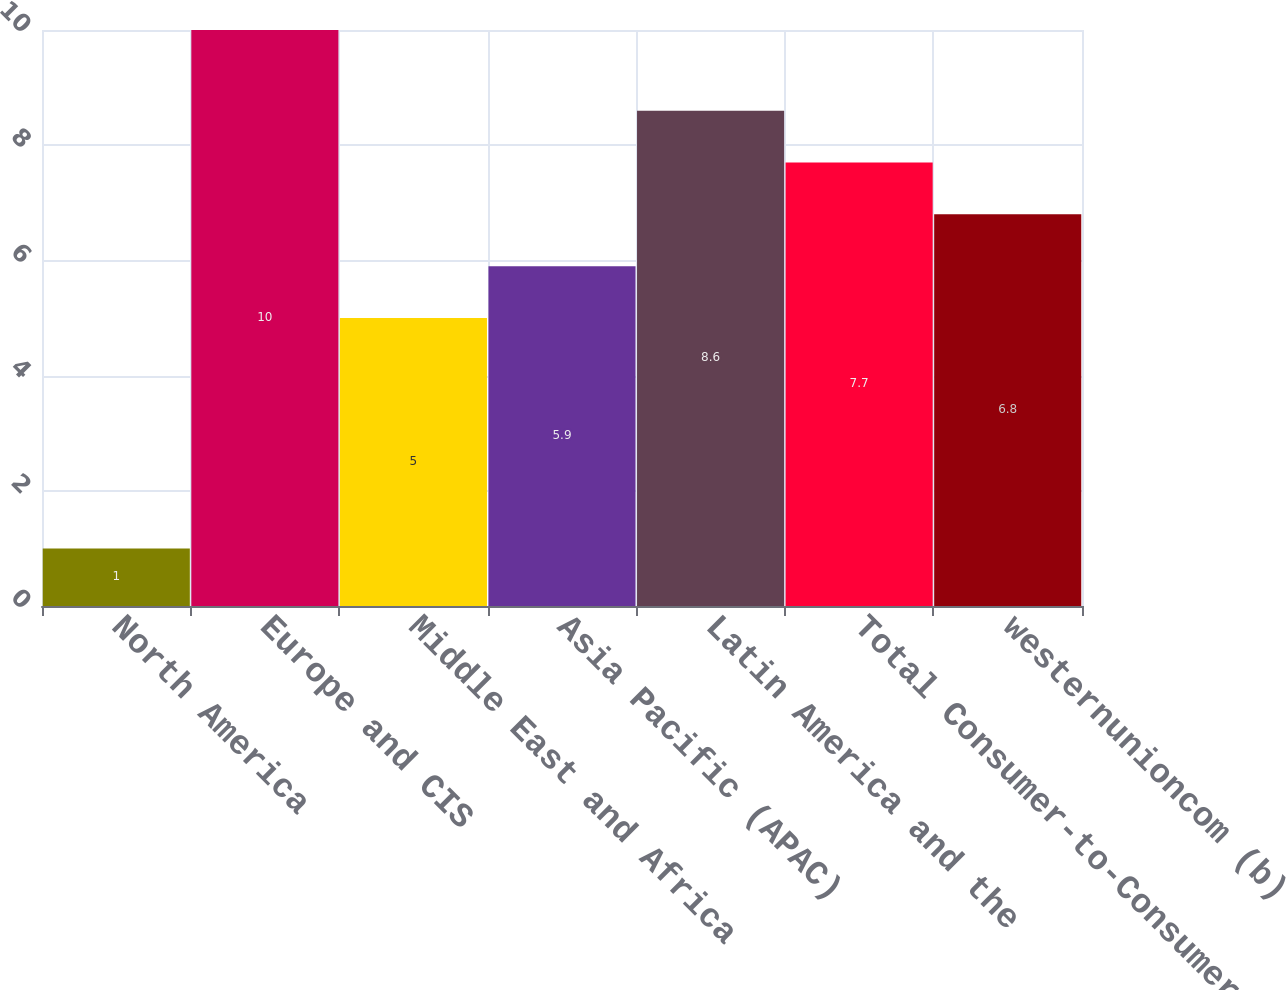Convert chart. <chart><loc_0><loc_0><loc_500><loc_500><bar_chart><fcel>North America<fcel>Europe and CIS<fcel>Middle East and Africa<fcel>Asia Pacific (APAC)<fcel>Latin America and the<fcel>Total Consumer-to-Consumer<fcel>westernunioncom (b)<nl><fcel>1<fcel>10<fcel>5<fcel>5.9<fcel>8.6<fcel>7.7<fcel>6.8<nl></chart> 